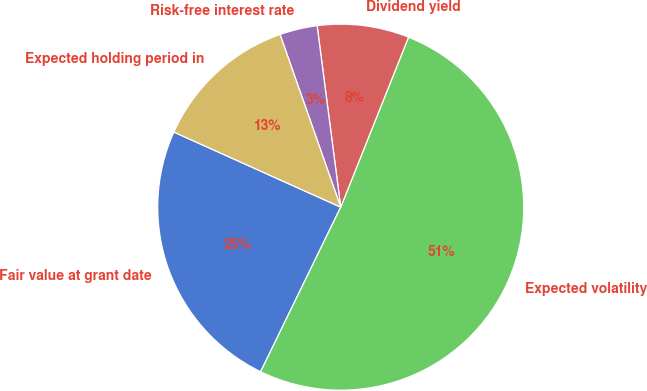Convert chart to OTSL. <chart><loc_0><loc_0><loc_500><loc_500><pie_chart><fcel>Fair value at grant date<fcel>Expected volatility<fcel>Dividend yield<fcel>Risk-free interest rate<fcel>Expected holding period in<nl><fcel>24.52%<fcel>51.17%<fcel>8.1%<fcel>3.32%<fcel>12.89%<nl></chart> 